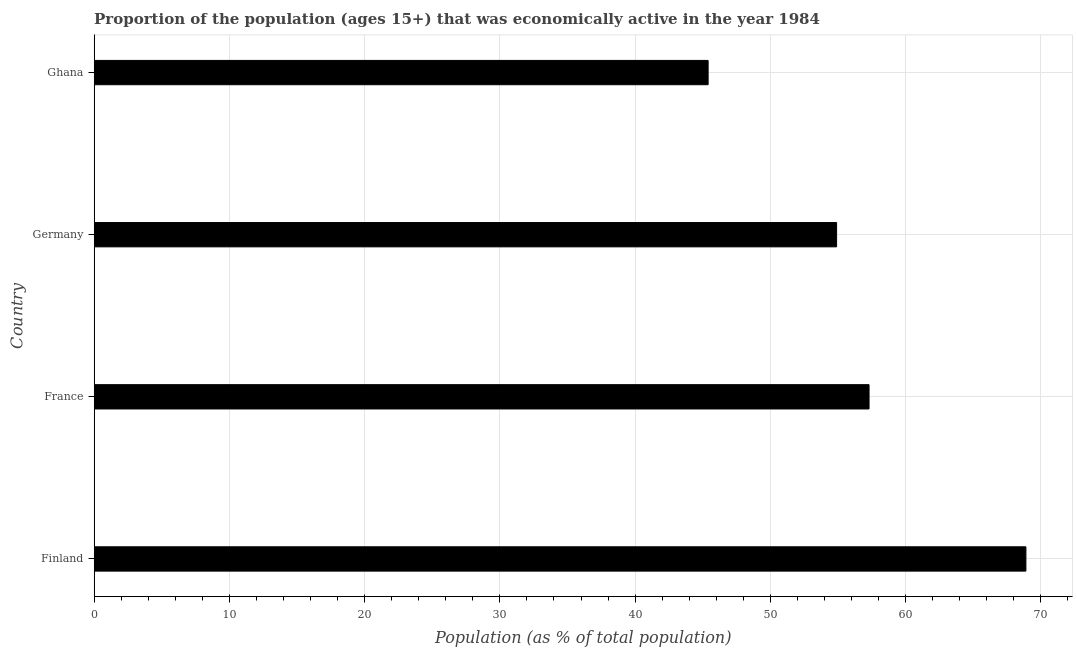What is the title of the graph?
Offer a very short reply. Proportion of the population (ages 15+) that was economically active in the year 1984. What is the label or title of the X-axis?
Ensure brevity in your answer.  Population (as % of total population). What is the label or title of the Y-axis?
Your answer should be compact. Country. What is the percentage of economically active population in France?
Offer a very short reply. 57.3. Across all countries, what is the maximum percentage of economically active population?
Keep it short and to the point. 68.9. Across all countries, what is the minimum percentage of economically active population?
Your answer should be very brief. 45.4. What is the sum of the percentage of economically active population?
Keep it short and to the point. 226.5. What is the average percentage of economically active population per country?
Provide a short and direct response. 56.62. What is the median percentage of economically active population?
Make the answer very short. 56.1. What is the ratio of the percentage of economically active population in France to that in Ghana?
Give a very brief answer. 1.26. Is the percentage of economically active population in Finland less than that in Ghana?
Make the answer very short. No. Is the sum of the percentage of economically active population in France and Ghana greater than the maximum percentage of economically active population across all countries?
Give a very brief answer. Yes. In how many countries, is the percentage of economically active population greater than the average percentage of economically active population taken over all countries?
Your answer should be very brief. 2. Are the values on the major ticks of X-axis written in scientific E-notation?
Offer a very short reply. No. What is the Population (as % of total population) in Finland?
Offer a very short reply. 68.9. What is the Population (as % of total population) in France?
Offer a very short reply. 57.3. What is the Population (as % of total population) of Germany?
Offer a very short reply. 54.9. What is the Population (as % of total population) in Ghana?
Make the answer very short. 45.4. What is the ratio of the Population (as % of total population) in Finland to that in France?
Give a very brief answer. 1.2. What is the ratio of the Population (as % of total population) in Finland to that in Germany?
Your response must be concise. 1.25. What is the ratio of the Population (as % of total population) in Finland to that in Ghana?
Offer a terse response. 1.52. What is the ratio of the Population (as % of total population) in France to that in Germany?
Keep it short and to the point. 1.04. What is the ratio of the Population (as % of total population) in France to that in Ghana?
Your answer should be compact. 1.26. What is the ratio of the Population (as % of total population) in Germany to that in Ghana?
Offer a terse response. 1.21. 